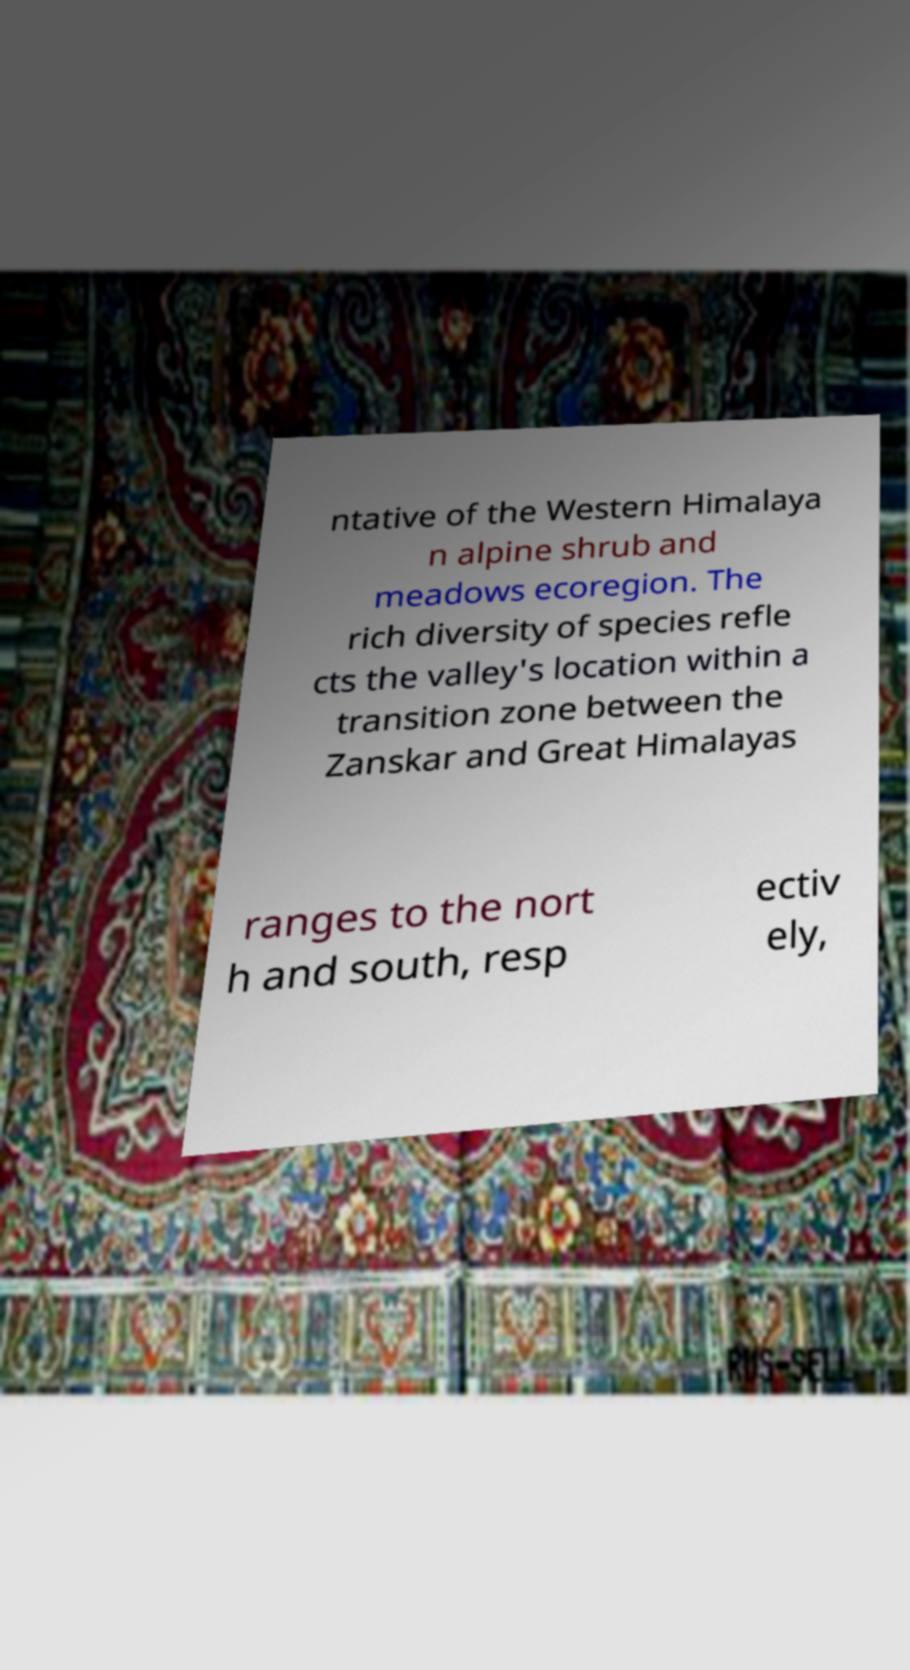What messages or text are displayed in this image? I need them in a readable, typed format. ntative of the Western Himalaya n alpine shrub and meadows ecoregion. The rich diversity of species refle cts the valley's location within a transition zone between the Zanskar and Great Himalayas ranges to the nort h and south, resp ectiv ely, 